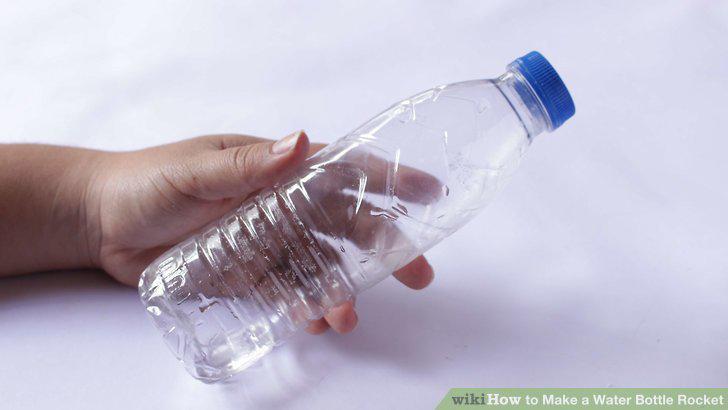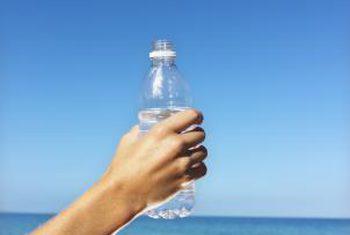The first image is the image on the left, the second image is the image on the right. Examine the images to the left and right. Is the description "Each image shows exactly one hand holding one water bottle." accurate? Answer yes or no. Yes. The first image is the image on the left, the second image is the image on the right. Evaluate the accuracy of this statement regarding the images: "The left and right image contains the same number of water bottles and hands.". Is it true? Answer yes or no. Yes. 